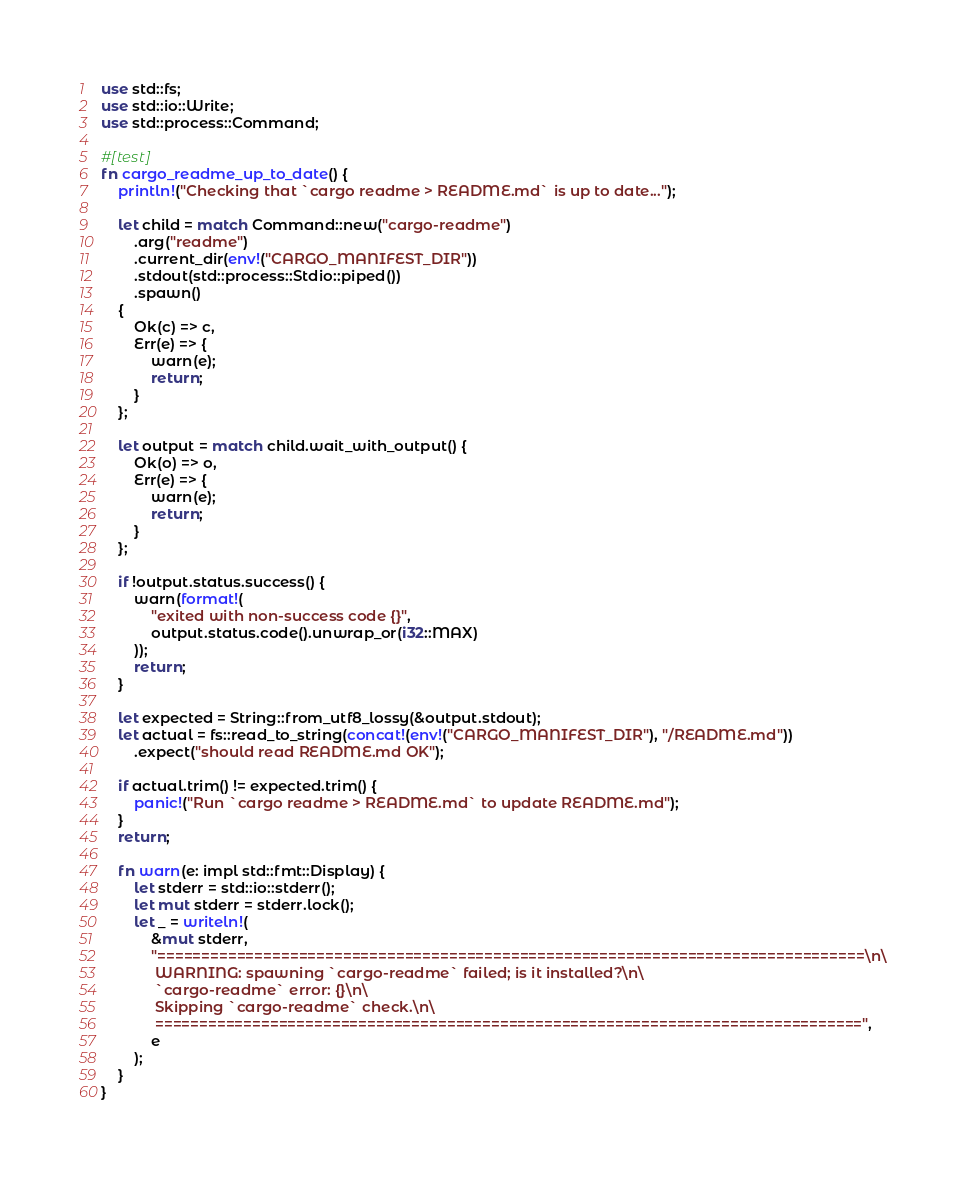Convert code to text. <code><loc_0><loc_0><loc_500><loc_500><_Rust_>use std::fs;
use std::io::Write;
use std::process::Command;

#[test]
fn cargo_readme_up_to_date() {
    println!("Checking that `cargo readme > README.md` is up to date...");

    let child = match Command::new("cargo-readme")
        .arg("readme")
        .current_dir(env!("CARGO_MANIFEST_DIR"))
        .stdout(std::process::Stdio::piped())
        .spawn()
    {
        Ok(c) => c,
        Err(e) => {
            warn(e);
            return;
        }
    };

    let output = match child.wait_with_output() {
        Ok(o) => o,
        Err(e) => {
            warn(e);
            return;
        }
    };

    if !output.status.success() {
        warn(format!(
            "exited with non-success code {}",
            output.status.code().unwrap_or(i32::MAX)
        ));
        return;
    }

    let expected = String::from_utf8_lossy(&output.stdout);
    let actual = fs::read_to_string(concat!(env!("CARGO_MANIFEST_DIR"), "/README.md"))
        .expect("should read README.md OK");

    if actual.trim() != expected.trim() {
        panic!("Run `cargo readme > README.md` to update README.md");
    }
    return;

    fn warn(e: impl std::fmt::Display) {
        let stderr = std::io::stderr();
        let mut stderr = stderr.lock();
        let _ = writeln!(
            &mut stderr,
            "================================================================================\n\
             WARNING: spawning `cargo-readme` failed; is it installed?\n\
             `cargo-readme` error: {}\n\
             Skipping `cargo-readme` check.\n\
             ================================================================================",
            e
        );
    }
}
</code> 